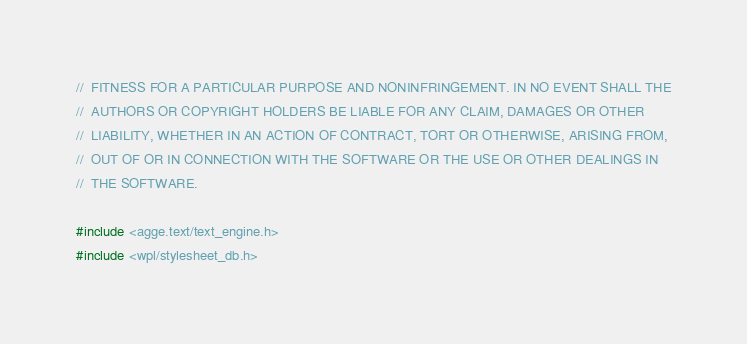Convert code to text. <code><loc_0><loc_0><loc_500><loc_500><_C++_>//	FITNESS FOR A PARTICULAR PURPOSE AND NONINFRINGEMENT. IN NO EVENT SHALL THE
//	AUTHORS OR COPYRIGHT HOLDERS BE LIABLE FOR ANY CLAIM, DAMAGES OR OTHER
//	LIABILITY, WHETHER IN AN ACTION OF CONTRACT, TORT OR OTHERWISE, ARISING FROM,
//	OUT OF OR IN CONNECTION WITH THE SOFTWARE OR THE USE OR OTHER DEALINGS IN
//	THE SOFTWARE.

#include <agge.text/text_engine.h>
#include <wpl/stylesheet_db.h></code> 